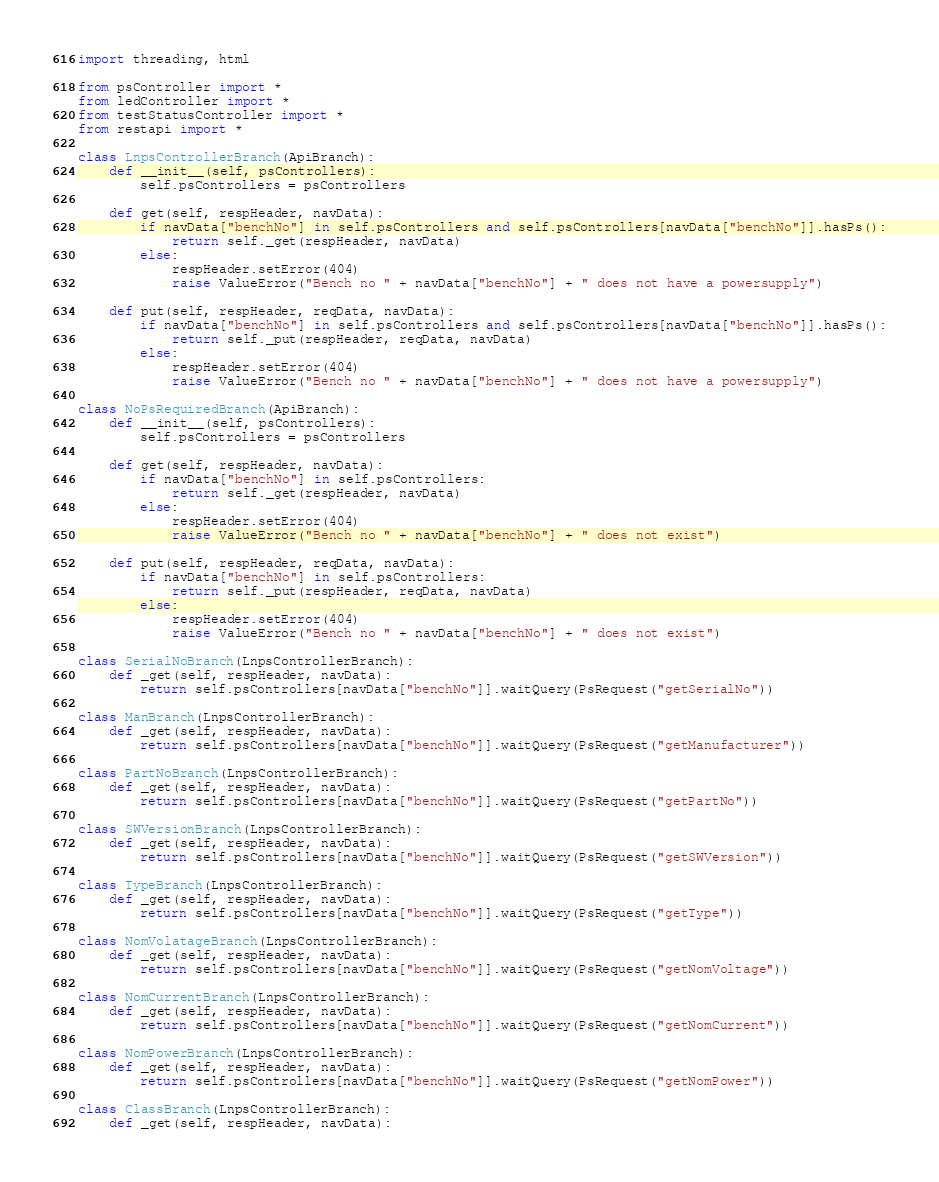Convert code to text. <code><loc_0><loc_0><loc_500><loc_500><_Python_>import threading, html

from psController import *
from ledController import *
from testStatusController import *
from restapi import *

class LnpsControllerBranch(ApiBranch):
	def __init__(self, psControllers):
		self.psControllers = psControllers
		
	def get(self, respHeader, navData):
		if navData["benchNo"] in self.psControllers and self.psControllers[navData["benchNo"]].hasPs():
			return self._get(respHeader, navData)
		else:
			respHeader.setError(404)
			raise ValueError("Bench no " + navData["benchNo"] + " does not have a powersupply")
			
	def put(self, respHeader, reqData, navData):
		if navData["benchNo"] in self.psControllers and self.psControllers[navData["benchNo"]].hasPs():
			return self._put(respHeader, reqData, navData)
		else:
			respHeader.setError(404)
			raise ValueError("Bench no " + navData["benchNo"] + " does not have a powersupply")
	
class NoPsRequiredBranch(ApiBranch):
	def __init__(self, psControllers):
		self.psControllers = psControllers
		
	def get(self, respHeader, navData):	
		if navData["benchNo"] in self.psControllers:
			return self._get(respHeader, navData)
		else:
			respHeader.setError(404)
			raise ValueError("Bench no " + navData["benchNo"] + " does not exist")
	
	def put(self, respHeader, reqData, navData):	
		if navData["benchNo"] in self.psControllers:
			return self._put(respHeader, reqData, navData)
		else:
			respHeader.setError(404)
			raise ValueError("Bench no " + navData["benchNo"] + " does not exist")
	
class SerialNoBranch(LnpsControllerBranch):
	def _get(self, respHeader, navData):
		return self.psControllers[navData["benchNo"]].waitQuery(PsRequest("getSerialNo"))
		
class ManBranch(LnpsControllerBranch):
	def _get(self, respHeader, navData):
		return self.psControllers[navData["benchNo"]].waitQuery(PsRequest("getManufacturer"))
		
class PartNoBranch(LnpsControllerBranch):
	def _get(self, respHeader, navData):
		return self.psControllers[navData["benchNo"]].waitQuery(PsRequest("getPartNo"))
		
class SWVersionBranch(LnpsControllerBranch):
	def _get(self, respHeader, navData):
		return self.psControllers[navData["benchNo"]].waitQuery(PsRequest("getSWVersion"))
		
class TypeBranch(LnpsControllerBranch):
	def _get(self, respHeader, navData):
		return self.psControllers[navData["benchNo"]].waitQuery(PsRequest("getType"))
		
class NomVolatageBranch(LnpsControllerBranch):
	def _get(self, respHeader, navData):
		return self.psControllers[navData["benchNo"]].waitQuery(PsRequest("getNomVoltage"))
		
class NomCurrentBranch(LnpsControllerBranch):
	def _get(self, respHeader, navData):
		return self.psControllers[navData["benchNo"]].waitQuery(PsRequest("getNomCurrent"))
		
class NomPowerBranch(LnpsControllerBranch):
	def _get(self, respHeader, navData):
		return self.psControllers[navData["benchNo"]].waitQuery(PsRequest("getNomPower"))
		
class ClassBranch(LnpsControllerBranch):
	def _get(self, respHeader, navData):</code> 